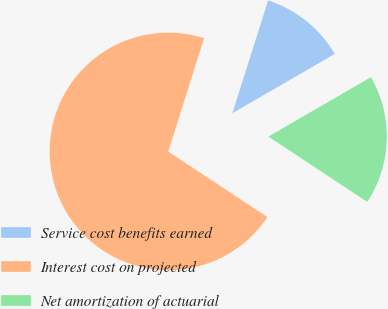<chart> <loc_0><loc_0><loc_500><loc_500><pie_chart><fcel>Service cost benefits earned<fcel>Interest cost on projected<fcel>Net amortization of actuarial<nl><fcel>11.76%<fcel>70.59%<fcel>17.65%<nl></chart> 